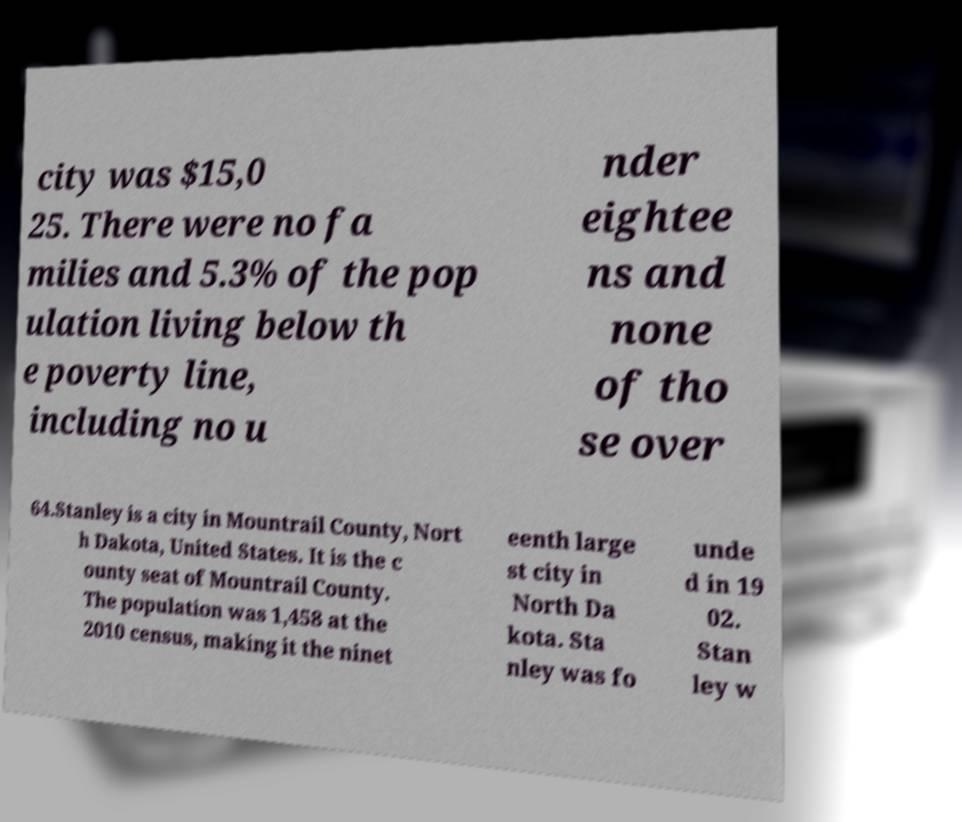Please read and relay the text visible in this image. What does it say? city was $15,0 25. There were no fa milies and 5.3% of the pop ulation living below th e poverty line, including no u nder eightee ns and none of tho se over 64.Stanley is a city in Mountrail County, Nort h Dakota, United States. It is the c ounty seat of Mountrail County. The population was 1,458 at the 2010 census, making it the ninet eenth large st city in North Da kota. Sta nley was fo unde d in 19 02. Stan ley w 